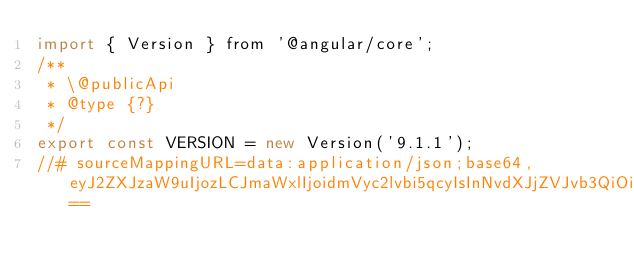<code> <loc_0><loc_0><loc_500><loc_500><_JavaScript_>import { Version } from '@angular/core';
/**
 * \@publicApi
 * @type {?}
 */
export const VERSION = new Version('9.1.1');
//# sourceMappingURL=data:application/json;base64,eyJ2ZXJzaW9uIjozLCJmaWxlIjoidmVyc2lvbi5qcyIsInNvdXJjZVJvb3QiOiIiLCJzb3VyY2VzIjpbIi4uLy4uLy4uLy4uLy4uLy4uL3BhY2thZ2VzL3BsYXRmb3JtLWJyb3dzZXItZHluYW1pYy9zcmMvdmVyc2lvbi50cyJdLCJuYW1lcyI6W10sIm1hcHBpbmdzIjoiOzs7Ozs7Ozs7Ozs7Ozs7OztBQWNBLE9BQU8sRUFBQyxPQUFPLEVBQUMsTUFBTSxlQUFlLENBQUM7Ozs7O0FBS3RDLE1BQU0sT0FBTyxPQUFPLEdBQUcsSUFBSSxPQUFPLENBQUMsbUJBQW1CLENBQUMiLCJzb3VyY2VzQ29udGVudCI6WyIvKipcbiAqIEBsaWNlbnNlXG4gKiBDb3B5cmlnaHQgR29vZ2xlIEluYy4gQWxsIFJpZ2h0cyBSZXNlcnZlZC5cbiAqXG4gKiBVc2Ugb2YgdGhpcyBzb3VyY2UgY29kZSBpcyBnb3Zlcm5lZCBieSBhbiBNSVQtc3R5bGUgbGljZW5zZSB0aGF0IGNhbiBiZVxuICogZm91bmQgaW4gdGhlIExJQ0VOU0UgZmlsZSBhdCBodHRwczovL2FuZ3VsYXIuaW8vbGljZW5zZVxuICovXG5cbi8qKlxuICogQG1vZHVsZVxuICogQGRlc2NyaXB0aW9uXG4gKiBFbnRyeSBwb2ludCBmb3IgYWxsIHB1YmxpYyBBUElzIG9mIHRoZSBjb21tb24gcGFja2FnZS5cbiAqL1xuXG5pbXBvcnQge1ZlcnNpb259IGZyb20gJ0Bhbmd1bGFyL2NvcmUnO1xuXG4vKipcbiAqIEBwdWJsaWNBcGlcbiAqL1xuZXhwb3J0IGNvbnN0IFZFUlNJT04gPSBuZXcgVmVyc2lvbignMC4wLjAtUExBQ0VIT0xERVInKTtcbiJdfQ==</code> 